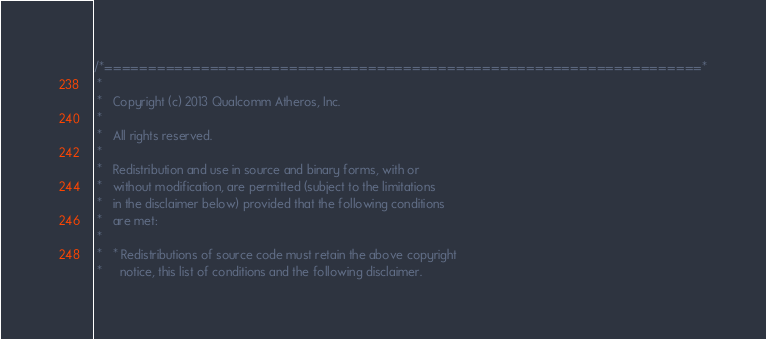<code> <loc_0><loc_0><loc_500><loc_500><_C_>/*====================================================================*
 *
 *   Copyright (c) 2013 Qualcomm Atheros, Inc.
 *
 *   All rights reserved.
 *
 *   Redistribution and use in source and binary forms, with or 
 *   without modification, are permitted (subject to the limitations 
 *   in the disclaimer below) provided that the following conditions 
 *   are met:
 *
 *   * Redistributions of source code must retain the above copyright 
 *     notice, this list of conditions and the following disclaimer.</code> 